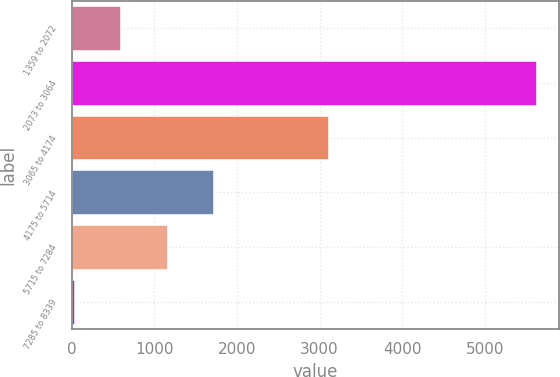Convert chart. <chart><loc_0><loc_0><loc_500><loc_500><bar_chart><fcel>1359 to 2072<fcel>2073 to 3064<fcel>3065 to 4174<fcel>4175 to 5714<fcel>5715 to 7284<fcel>7285 to 8339<nl><fcel>587.2<fcel>5620<fcel>3100<fcel>1705.6<fcel>1146.4<fcel>28<nl></chart> 